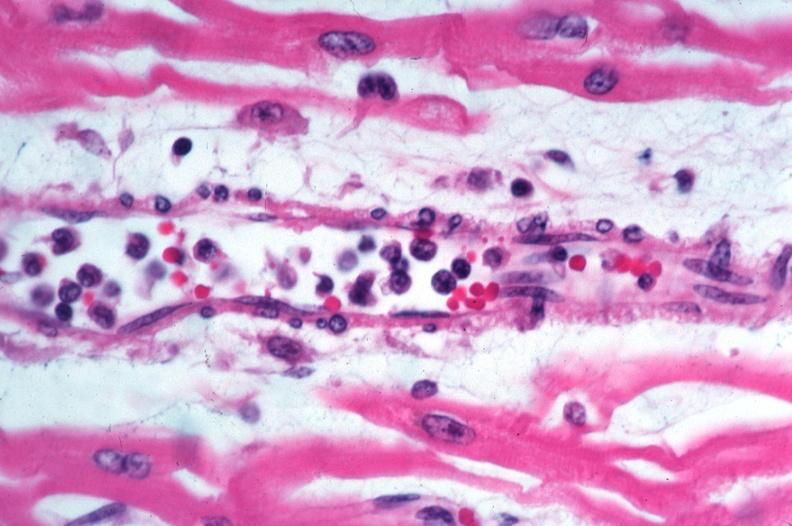s rocky mountain spotted fever, vasculitis?
Answer the question using a single word or phrase. Yes 